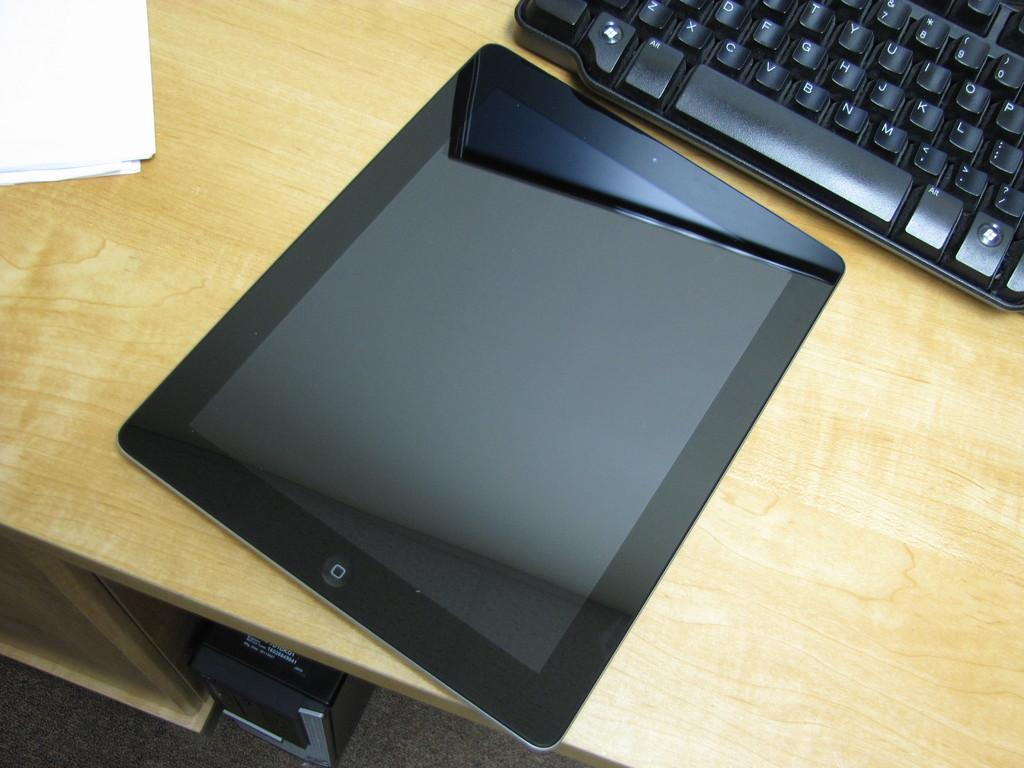<image>
Render a clear and concise summary of the photo. An Ipad sits on a desk next to the alt key on a keyboard. 